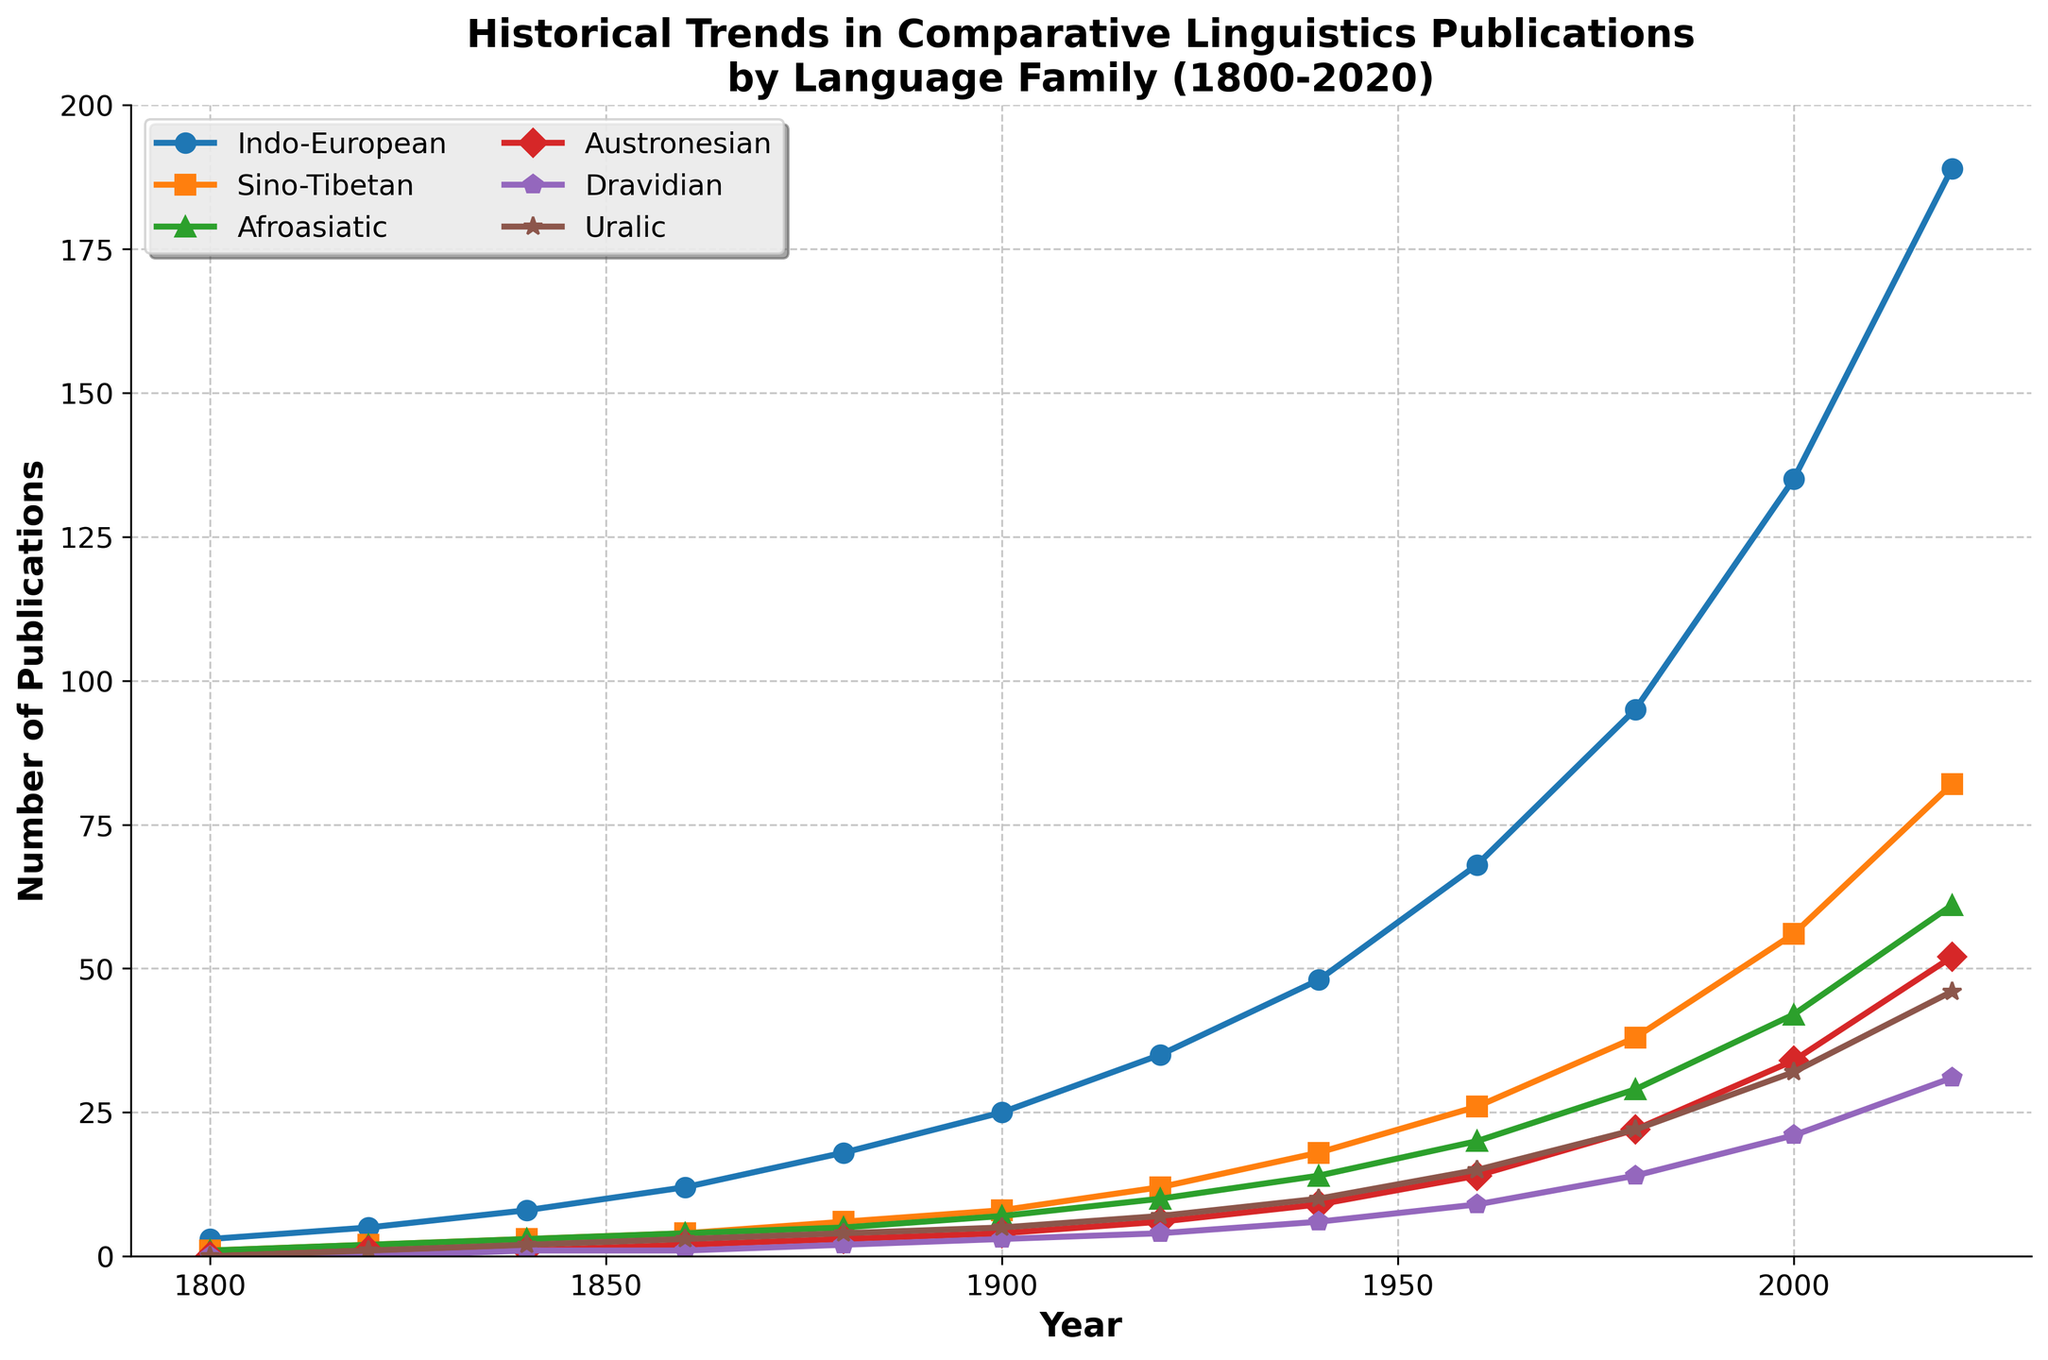what trend can be observed in the number of Indo-European publications from 1800 to 2020? From the figure, it is clear that the number of Indo-European publications has shown a steady increase over the years, starting from 3 in 1800 to 189 in 2020. This can be observed by noting how the line representing Indo-European publications slopes upward consistently.
Answer: Increasing trend Between which two decades did Sino-Tibetan publications experience the most significant growth? By examining the steepness of the lines and the difference in numbers, it appears that the most significant growth occurred between 2000 and 2020. The publications grew from 56 in 2000 to 82 in 2020, which is a difference of 26 publications.
Answer: 2000 and 2020 In which approximate year does the number of Dravidian publications surpass 20? By following the Dravidian line on the chart, it intersects the 20 mark between 1960 and 1980. More precisely, it surpasses 20 around the year 1980 as the chart shows 14 publications in 1980 and 21 in 2000.
Answer: 1980 How many total publications were there across all language families in 1860? Summing the values for all language families in 1860 (Indo-European: 12, Sino-Tibetan: 4, Afroasiatic: 4, Austronesian: 2, Dravidian: 1, Uralic: 3), the total number of publications is 12 + 4 + 4 + 2 + 1 + 3 = 26.
Answer: 26 Which language family had the highest number of publications in 1940, and how many were there? Observing the figure, Indo-European had the highest number of publications in 1940 with 48 publications. This can be identified by the highest point on the graph for 1940.
Answer: Indo-European, 48 What is the average number of publications for Afroasiatic across all recorded years? Summing up all the values for Afroasiatic across the years (1, 2, 3, 4, 5, 7, 10, 14, 20, 29, 42, 61) gives a total of 198. There are 12 data points, so the average is 198/12 = 16.5.
Answer: 16.5 Which language family showed the smallest growth from 1800 to 2020, and what was the growth amount? Uralic publications grew from 0 in 1800 to 46 in 2020. For other language families: Indo-European (186), Sino-Tibetan (81), Afroasiatic (60), Austronesian (52), Dravidian (31). Uralic shows a growth of 46, which is the smallest.
Answer: Uralic, 46 If the number of Austronesian publications doubled from 1920 to 1940, what would be the new value in 1940? The number of Austronesian publications in 1920 was 6. Doubling this number: 6 * 2 = 12, so the new value in 1940 would be 12.
Answer: 12 